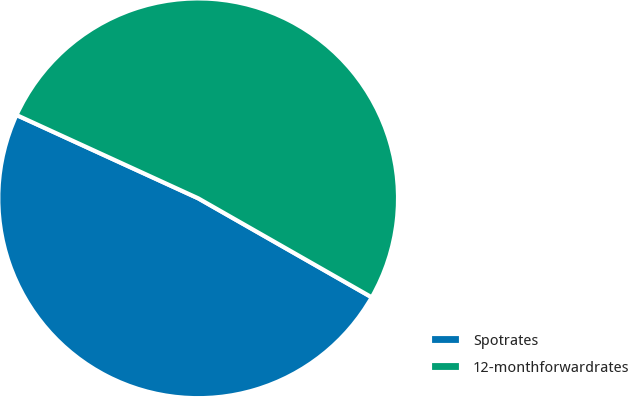Convert chart to OTSL. <chart><loc_0><loc_0><loc_500><loc_500><pie_chart><fcel>Spotrates<fcel>12-monthforwardrates<nl><fcel>48.59%<fcel>51.41%<nl></chart> 